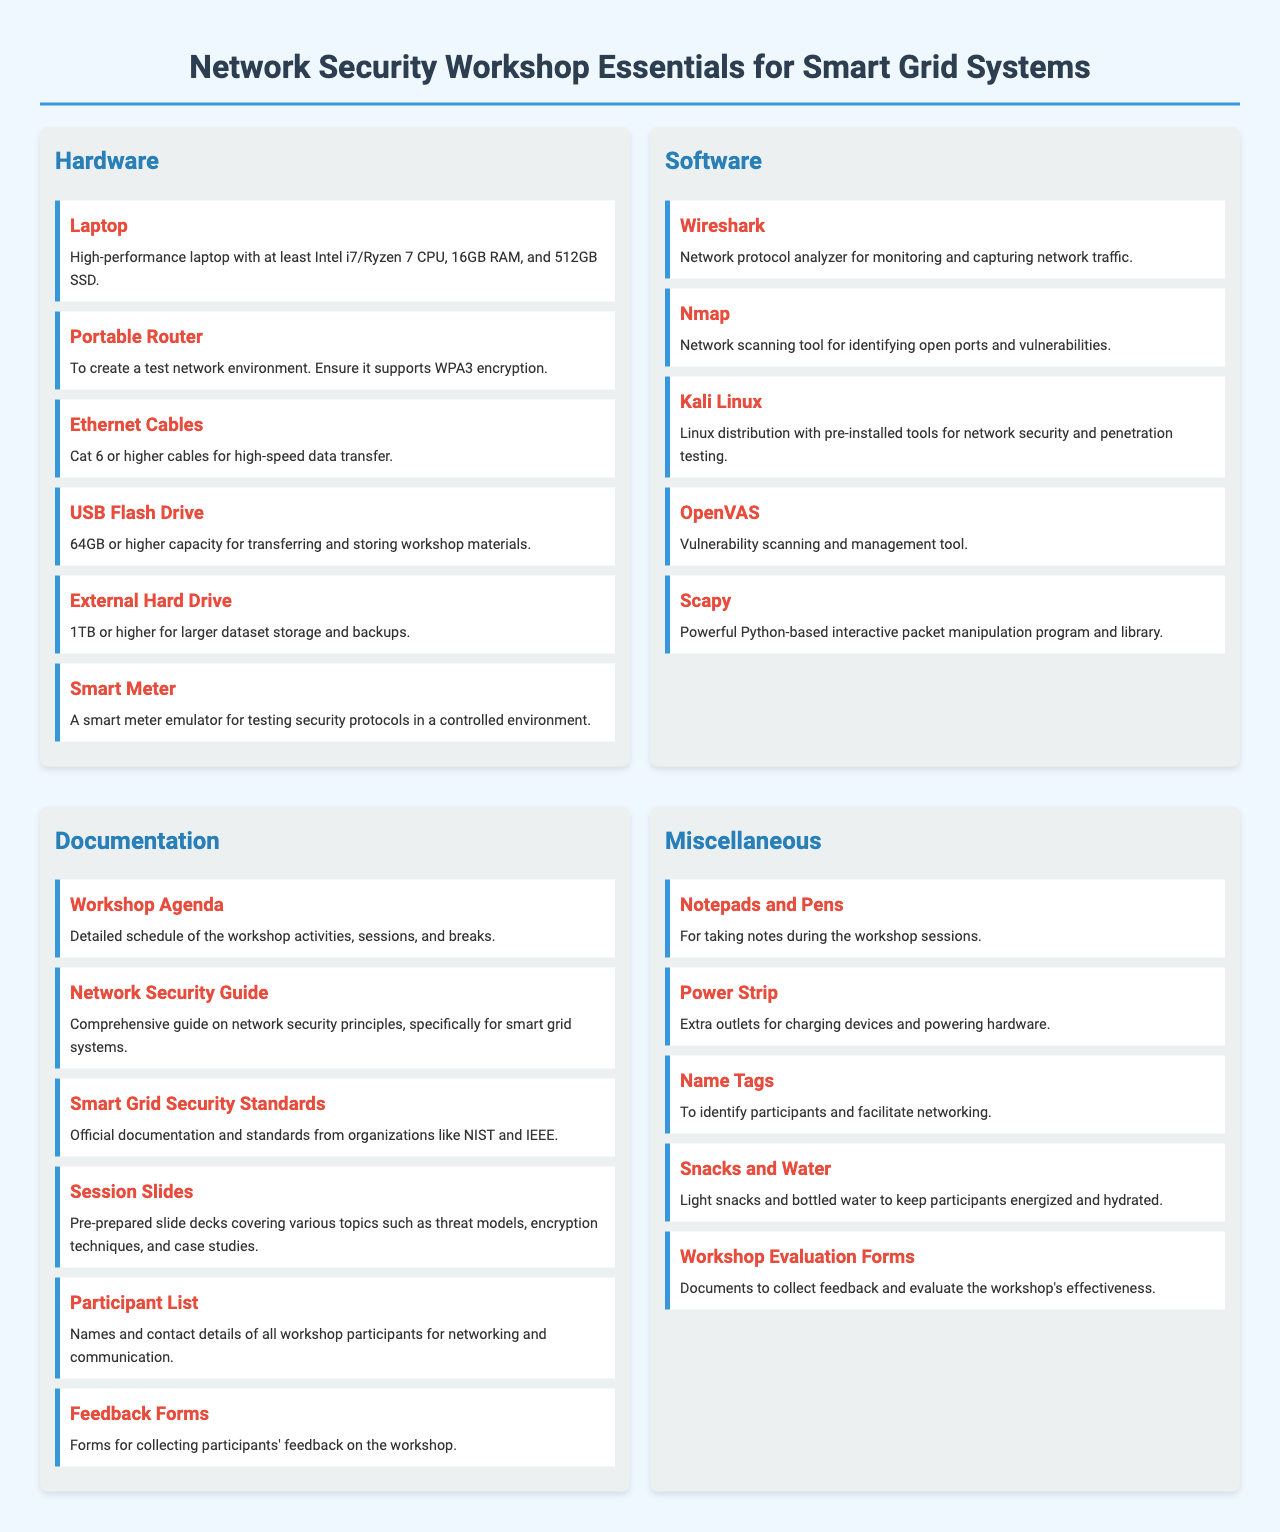What type of laptop is recommended? The document specifies the type of laptop required for the workshop, highlighting key specifications such as the CPU, RAM, and storage.
Answer: High-performance laptop with at least Intel i7/Ryzen 7 CPU, 16GB RAM, and 512GB SSD How many types of software are listed? The document contains a category for software, and the number of items listed in that category determines the answer.
Answer: Five What is the purpose of the Portable Router? The document outlines the function of the Portable Router, clarifying its role in the workshop.
Answer: To create a test network environment What document outlines the schedule of the workshop activities? The document provides specific titles for various pieces of documentation, one of which covers the workshop agenda.
Answer: Workshop Agenda What type of cables are recommended for high-speed data transfer? The specific type of cables suitable for high-speed data transfer is mentioned in the hardware section of the document.
Answer: Cat 6 or higher cables What are snacks and water for? The document indicates the purpose of providing snacks and water during the workshop, emphasizing the need for participant sustenance.
Answer: To keep participants energized and hydrated 